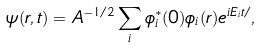Convert formula to latex. <formula><loc_0><loc_0><loc_500><loc_500>\psi ( { r } , t ) = A ^ { - 1 / 2 } \sum _ { i } \phi _ { i } ^ { * } ( { 0 } ) \phi _ { i } ( { r } ) e ^ { i E _ { i } t / } ,</formula> 